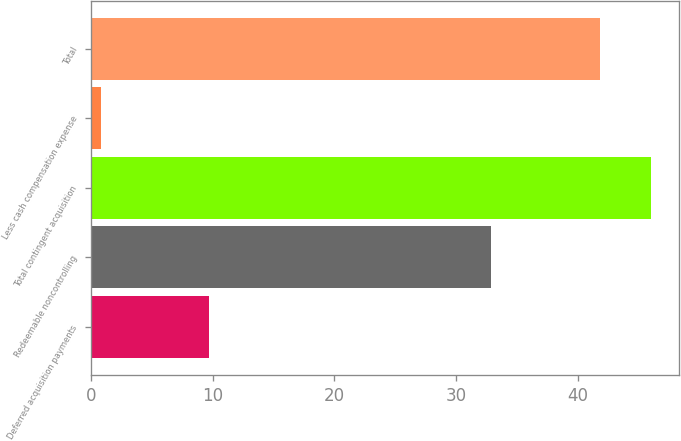Convert chart to OTSL. <chart><loc_0><loc_0><loc_500><loc_500><bar_chart><fcel>Deferred acquisition payments<fcel>Redeemable noncontrolling<fcel>Total contingent acquisition<fcel>Less cash compensation expense<fcel>Total<nl><fcel>9.7<fcel>32.9<fcel>45.98<fcel>0.8<fcel>41.8<nl></chart> 